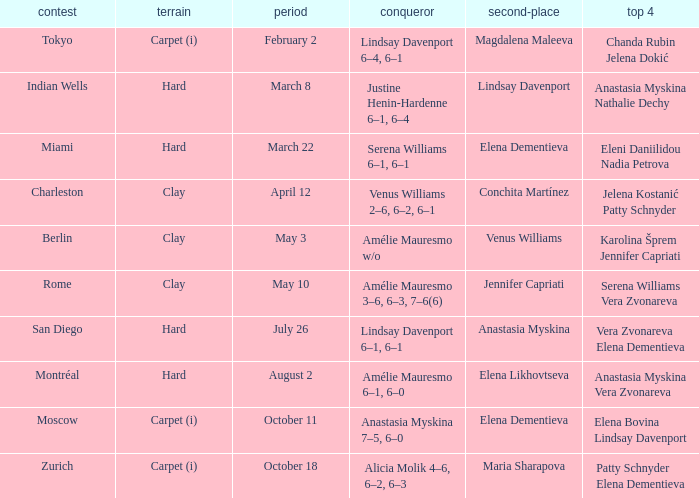Who was the winner of the Miami tournament where Elena Dementieva was a finalist? Serena Williams 6–1, 6–1. 